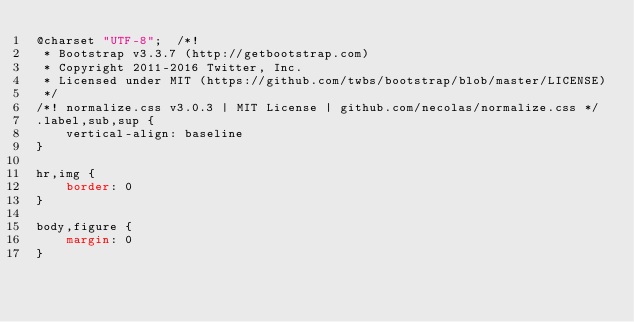<code> <loc_0><loc_0><loc_500><loc_500><_CSS_>@charset "UTF-8";  /*!
 * Bootstrap v3.3.7 (http://getbootstrap.com)
 * Copyright 2011-2016 Twitter, Inc.
 * Licensed under MIT (https://github.com/twbs/bootstrap/blob/master/LICENSE)
 */
/*! normalize.css v3.0.3 | MIT License | github.com/necolas/normalize.css */
.label,sub,sup {
	vertical-align: baseline
}

hr,img {
	border: 0
}

body,figure {
	margin: 0
}
</code> 